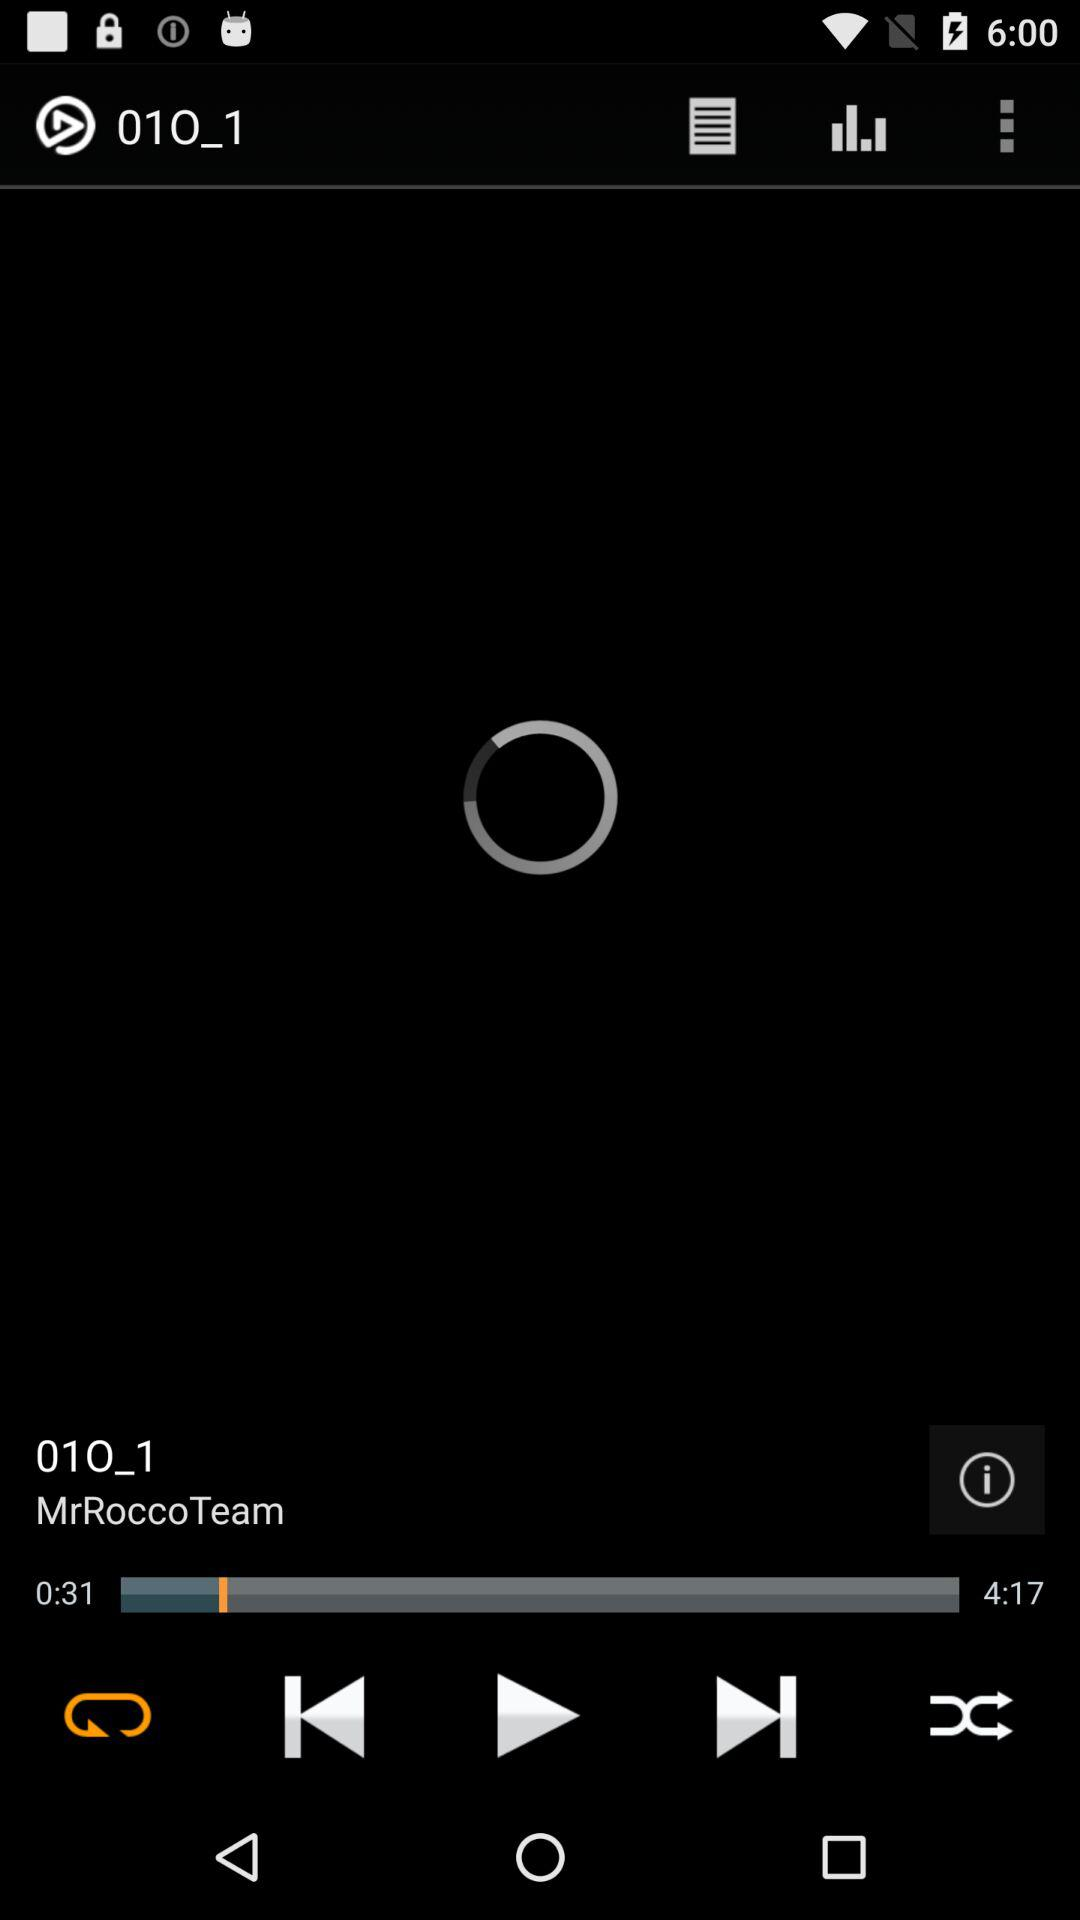What is the elapsed time of the audio? The elapsed time of the audio is 31 seconds. 